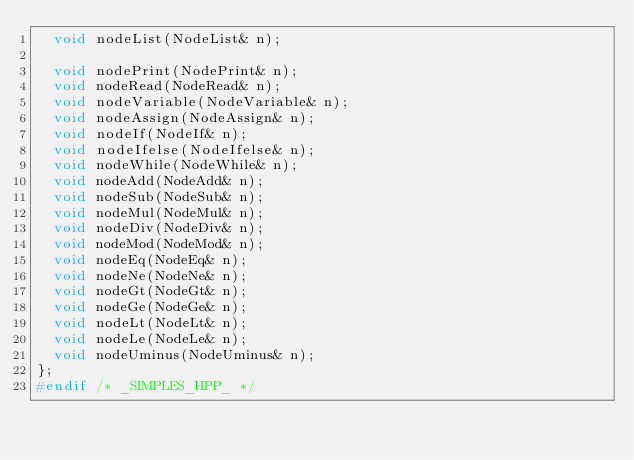Convert code to text. <code><loc_0><loc_0><loc_500><loc_500><_C++_>	void nodeList(NodeList& n);

	void nodePrint(NodePrint& n);
	void nodeRead(NodeRead& n);
	void nodeVariable(NodeVariable& n);
	void nodeAssign(NodeAssign& n);
	void nodeIf(NodeIf& n);
	void nodeIfelse(NodeIfelse& n);
	void nodeWhile(NodeWhile& n);
	void nodeAdd(NodeAdd& n);
	void nodeSub(NodeSub& n);
	void nodeMul(NodeMul& n);
	void nodeDiv(NodeDiv& n);
	void nodeMod(NodeMod& n);
	void nodeEq(NodeEq& n);
	void nodeNe(NodeNe& n);
	void nodeGt(NodeGt& n);
	void nodeGe(NodeGe& n);
	void nodeLt(NodeLt& n);
	void nodeLe(NodeLe& n);
	void nodeUminus(NodeUminus& n);
};
#endif /* _SIMPLES_HPP_ */
</code> 